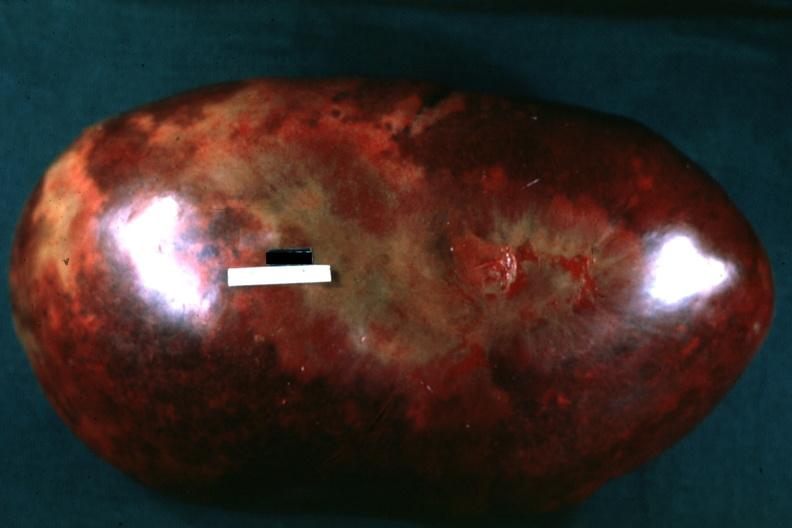s very good example present?
Answer the question using a single word or phrase. No 